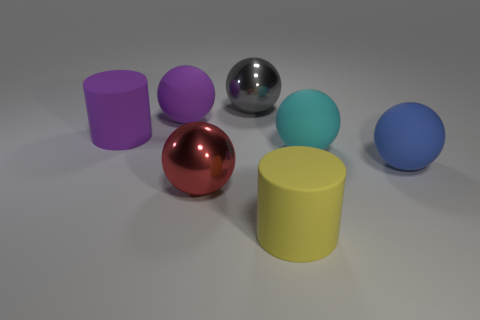Subtract all cyan balls. How many balls are left? 4 Subtract all green balls. Subtract all cyan cylinders. How many balls are left? 5 Add 1 big green rubber things. How many objects exist? 8 Subtract all cylinders. How many objects are left? 5 Add 6 blue matte spheres. How many blue matte spheres are left? 7 Add 5 small cyan shiny things. How many small cyan shiny things exist? 5 Subtract 0 green cubes. How many objects are left? 7 Subtract all gray things. Subtract all red spheres. How many objects are left? 5 